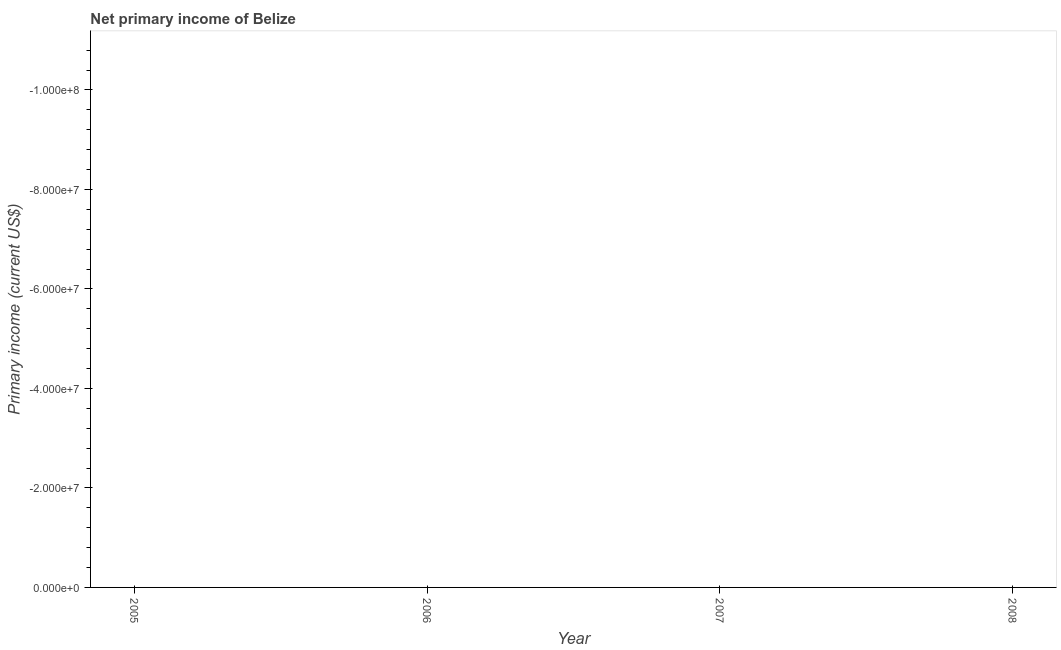What is the sum of the amount of primary income?
Your answer should be compact. 0. What is the average amount of primary income per year?
Your answer should be compact. 0. What is the median amount of primary income?
Your response must be concise. 0. In how many years, is the amount of primary income greater than -92000000 US$?
Your answer should be compact. 0. In how many years, is the amount of primary income greater than the average amount of primary income taken over all years?
Ensure brevity in your answer.  0. Does the amount of primary income monotonically increase over the years?
Your answer should be very brief. No. Are the values on the major ticks of Y-axis written in scientific E-notation?
Offer a terse response. Yes. Does the graph contain any zero values?
Keep it short and to the point. Yes. What is the title of the graph?
Provide a short and direct response. Net primary income of Belize. What is the label or title of the Y-axis?
Keep it short and to the point. Primary income (current US$). What is the Primary income (current US$) in 2007?
Offer a terse response. 0. What is the Primary income (current US$) of 2008?
Make the answer very short. 0. 